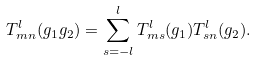<formula> <loc_0><loc_0><loc_500><loc_500>T _ { m n } ^ { l } ( g _ { 1 } g _ { 2 } ) = \sum _ { s = - l } ^ { l } T _ { m s } ^ { l } ( g _ { 1 } ) T _ { s n } ^ { l } ( g _ { 2 } ) .</formula> 